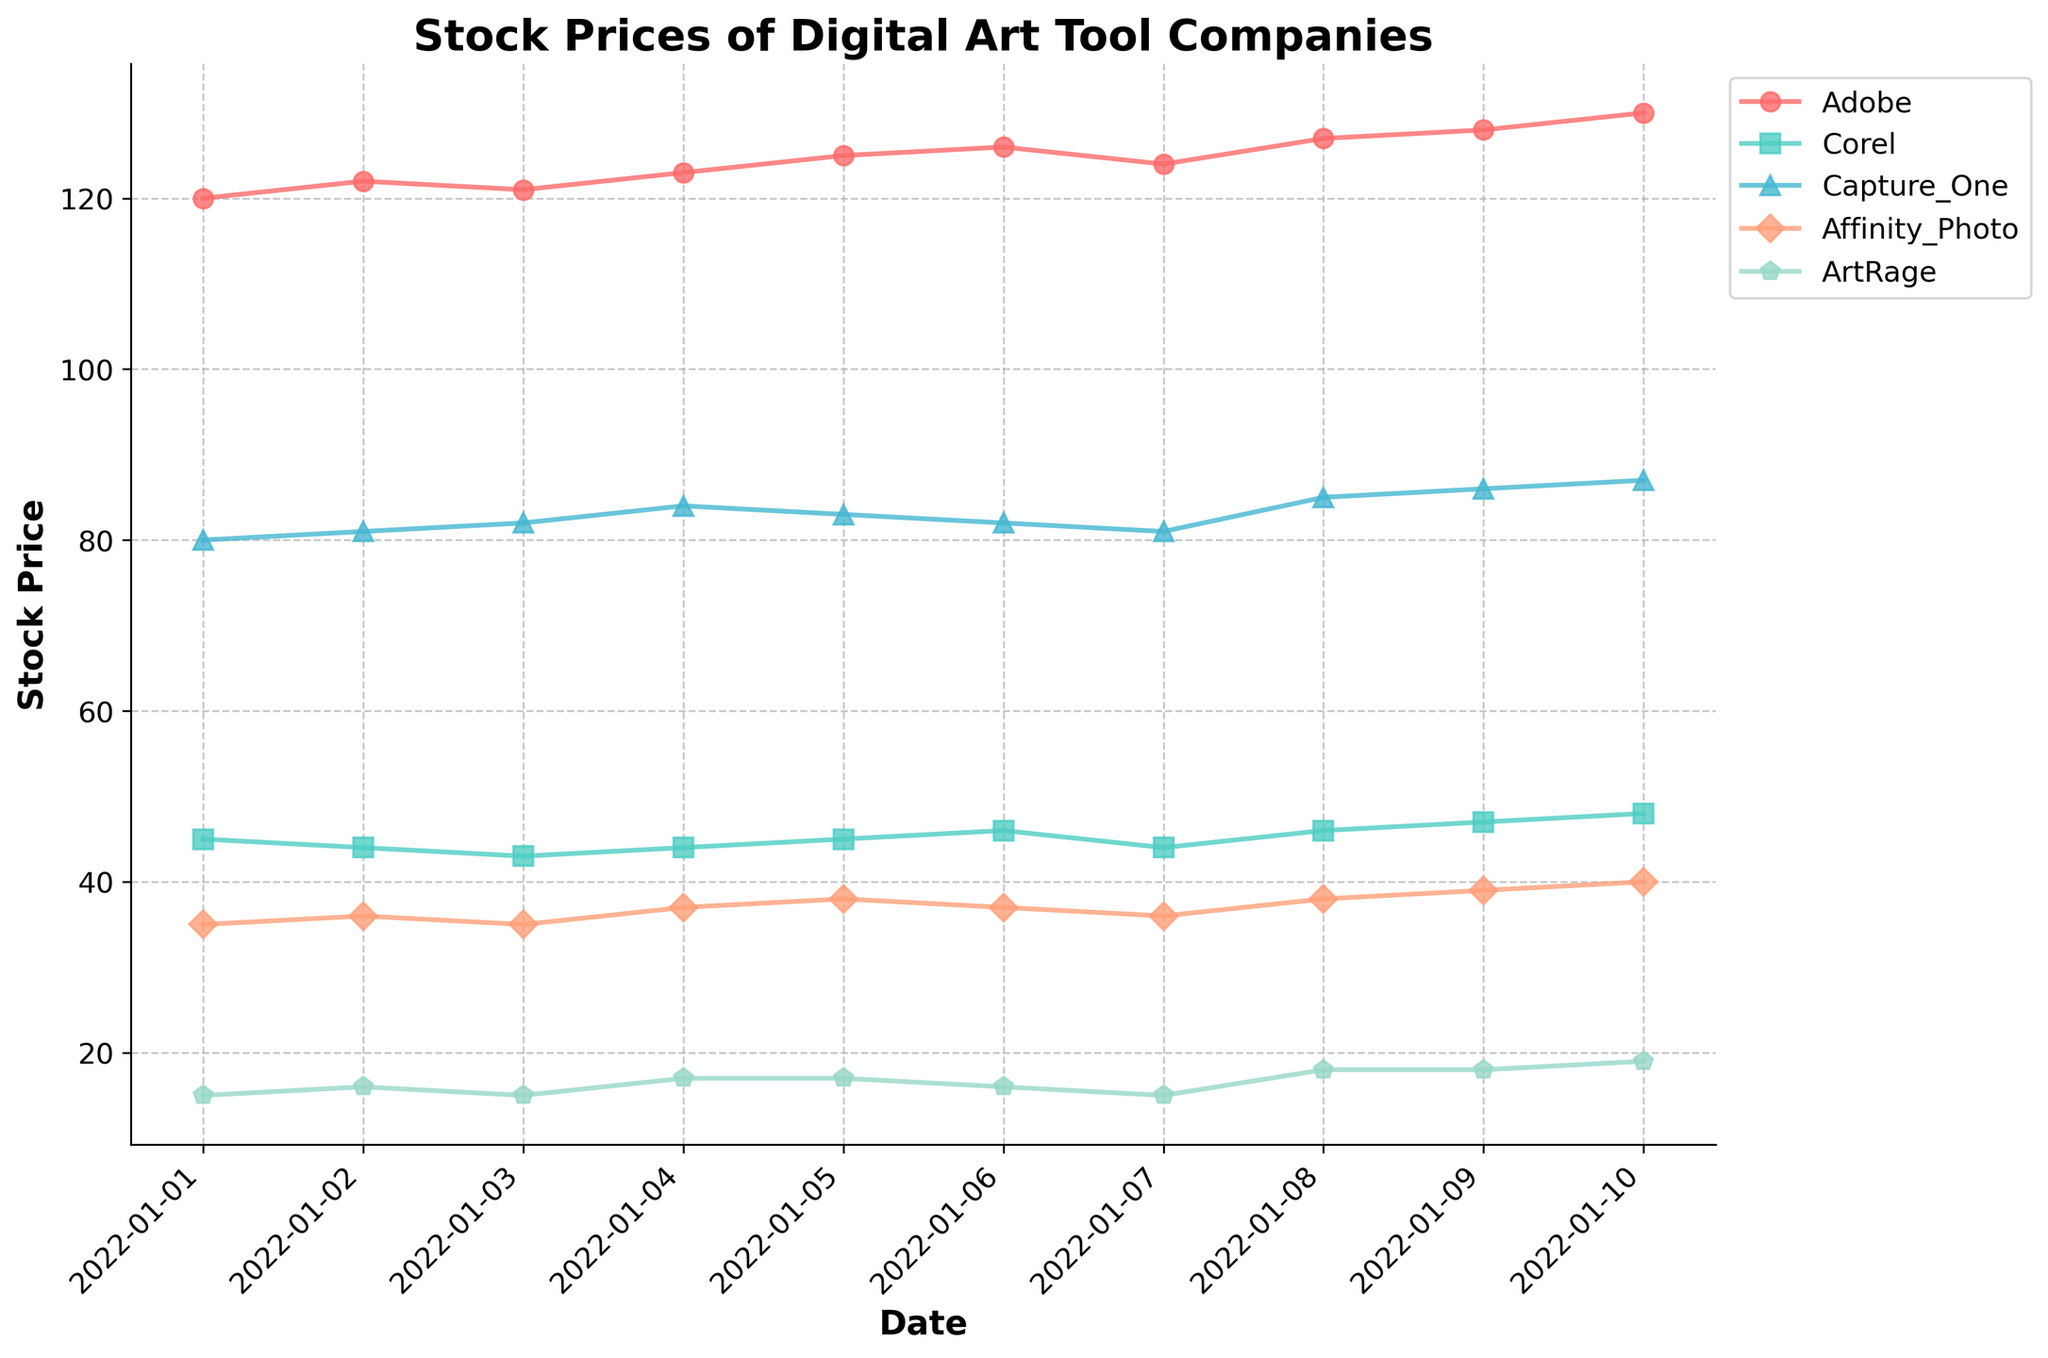What is the title of the plot? The title of the plot is written at the top of the figure. It provides an overview indicating the content of the plot.
Answer: Stock Prices of Digital Art Tool Companies What is the stock price of Adobe on January 7, 2022? By looking at the plot, find the point corresponding to January 7, 2022 on the x-axis and trace it to the Adobe line. The y-axis value at that point indicates the stock price.
Answer: 124 Which company's stock price had the highest value on January 10, 2022? Examine the values for all companies on January 10, 2022, by looking at the plot. Locate the highest point among them.
Answer: Adobe What was the increase in Adobe's stock price from January 1 to January 10, 2022? Find Adobe's stock prices on January 1 and January 10, 2022. Subtract the price on January 1 from the price on January 10.
Answer: 10 How many companies' stock prices are represented in the plot? Count the number of distinct lines in the plot, each representing a different company.
Answer: 5 On which date did Affinity Photo's stock price reach 40? Trace the Affinity Photo line on the plot and identify the date at which it touches the 40 mark on the y-axis.
Answer: January 10, 2022 What is the trend of Capture One's stock price over the period? Observe the overall direction of the Capture One line from the beginning to the end of the period.
Answer: Increasing Which two companies had identical stock prices on January 6, 2022? Compare the stock prices of all the companies on January 6, 2022, and identify which ones are the same.
Answer: Affinity Photo and Capture One Did ArtRage's stock price ever reach 20 during the period? Check the entire plot to see if the ArtRage line ever touches or exceeds the 20 mark on the y-axis.
Answer: No On which date did Corel's stock price drop to its lowest value? Find the lowest point of the Corel line on the y-axis and see which date corresponds to that point.
Answer: January 3, 2022 